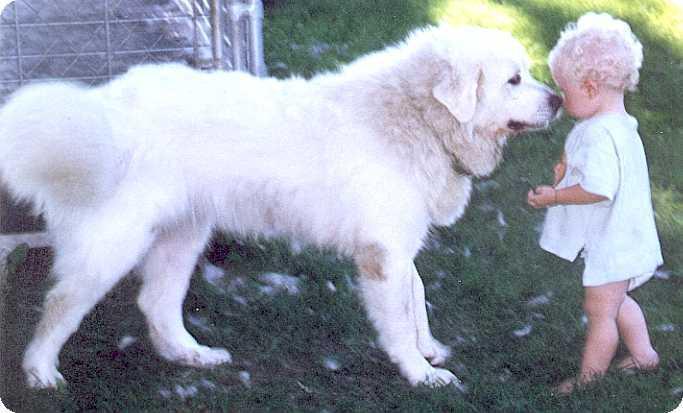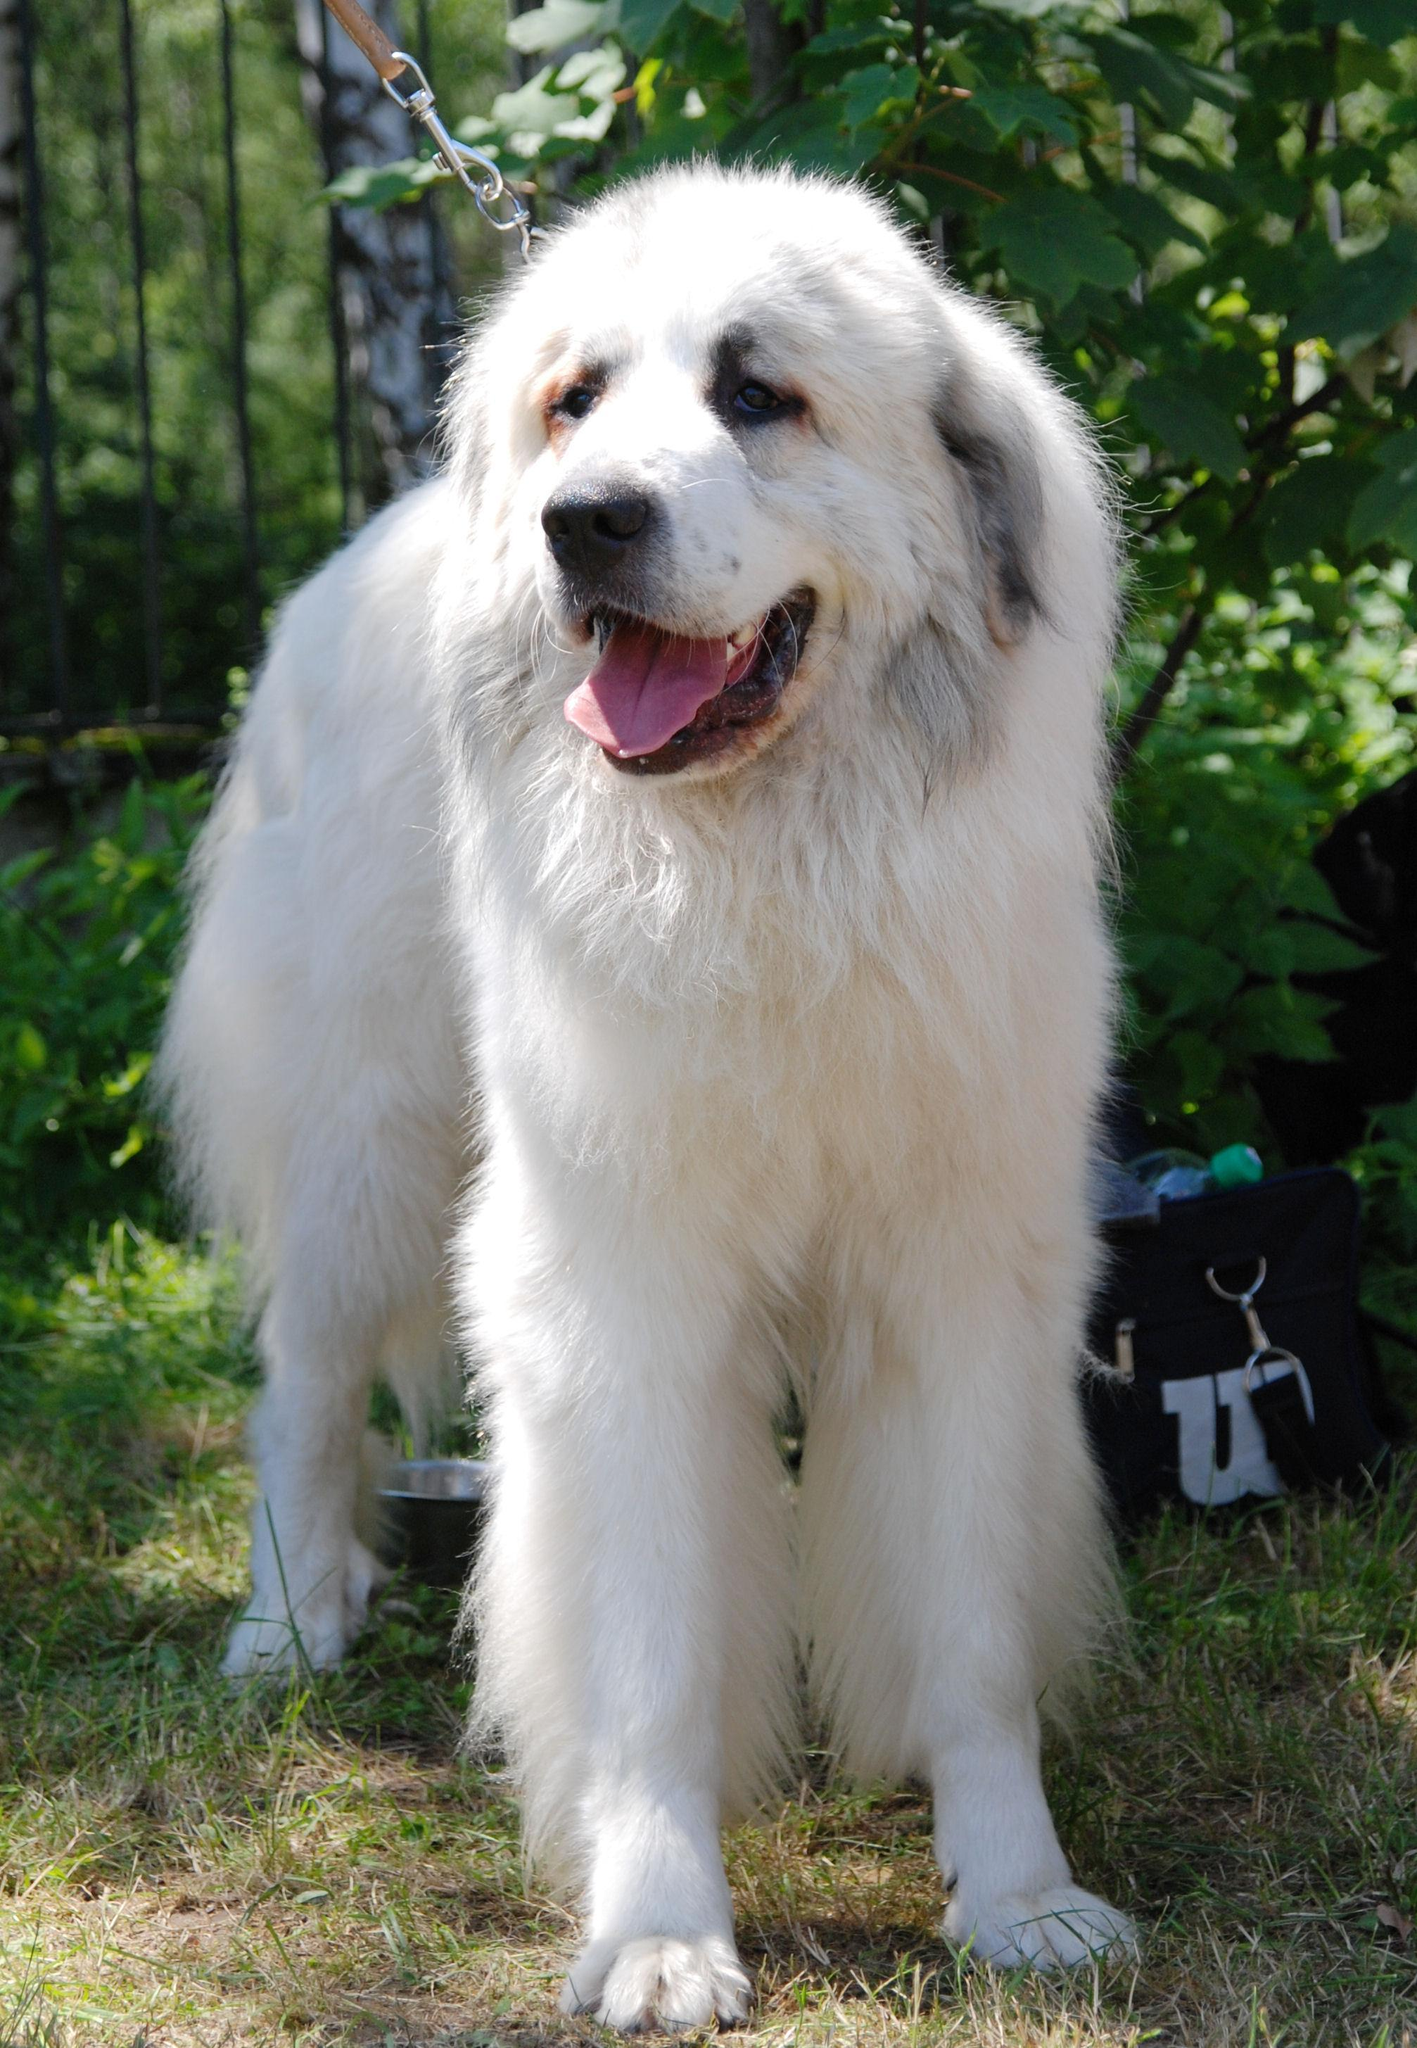The first image is the image on the left, the second image is the image on the right. Examine the images to the left and right. Is the description "The dog is interacting with a human in one picture." accurate? Answer yes or no. Yes. The first image is the image on the left, the second image is the image on the right. Evaluate the accuracy of this statement regarding the images: "dogs standing in a profile position facing to the left". Is it true? Answer yes or no. No. The first image is the image on the left, the second image is the image on the right. Evaluate the accuracy of this statement regarding the images: "A white dog is standing and facing right". Is it true? Answer yes or no. Yes. 